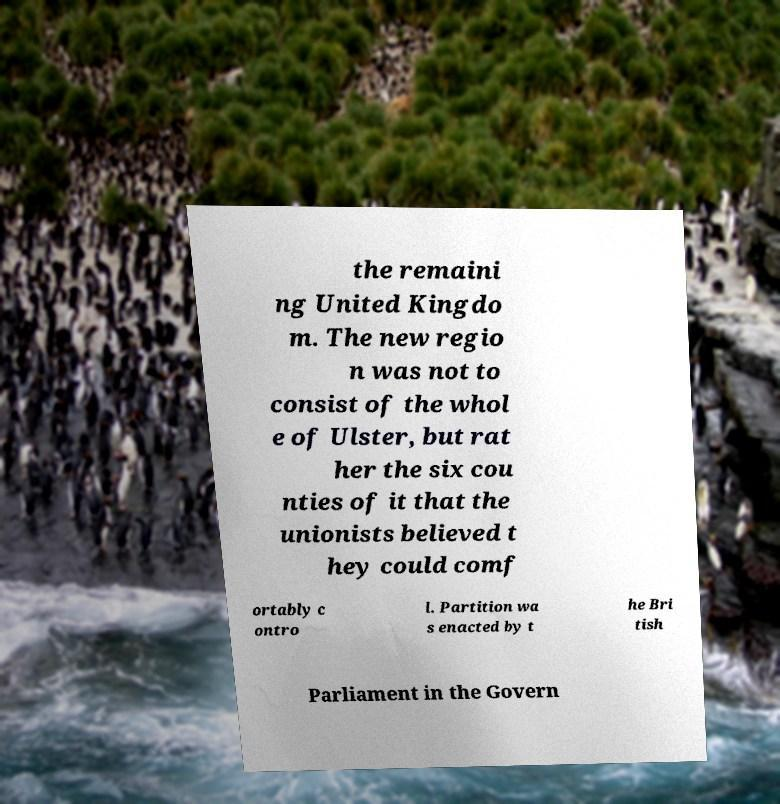What messages or text are displayed in this image? I need them in a readable, typed format. the remaini ng United Kingdo m. The new regio n was not to consist of the whol e of Ulster, but rat her the six cou nties of it that the unionists believed t hey could comf ortably c ontro l. Partition wa s enacted by t he Bri tish Parliament in the Govern 